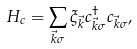<formula> <loc_0><loc_0><loc_500><loc_500>H _ { c } = \sum _ { \vec { k } \sigma } \xi _ { \vec { k } } c ^ { \dag } _ { \vec { k } \sigma } c _ { \vec { k } \sigma } ,</formula> 